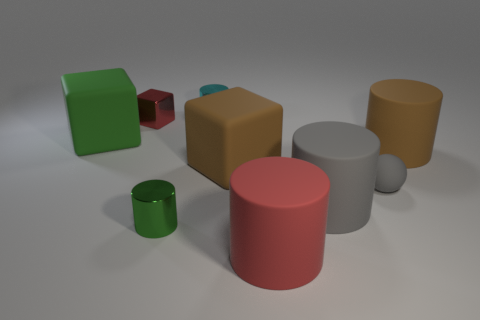Are the ball and the cylinder behind the red metal thing made of the same material?
Offer a terse response. No. What number of spheres are either cyan things or big brown rubber things?
Give a very brief answer. 0. How many tiny metallic cylinders are both in front of the large brown rubber cube and behind the tiny red cube?
Make the answer very short. 0. What color is the cylinder in front of the tiny green cylinder?
Your answer should be very brief. Red. What size is the green cylinder that is the same material as the tiny red object?
Ensure brevity in your answer.  Small. How many gray spheres are left of the red thing that is behind the big red matte cylinder?
Offer a very short reply. 0. What number of small cylinders are in front of the tiny matte sphere?
Offer a very short reply. 1. What color is the big thing to the left of the cube in front of the big brown object that is to the right of the brown matte cube?
Offer a terse response. Green. Does the matte object in front of the tiny green metallic thing have the same color as the small thing to the left of the tiny green object?
Give a very brief answer. Yes. The matte thing that is on the left side of the cylinder that is behind the tiny red metal thing is what shape?
Provide a short and direct response. Cube. 